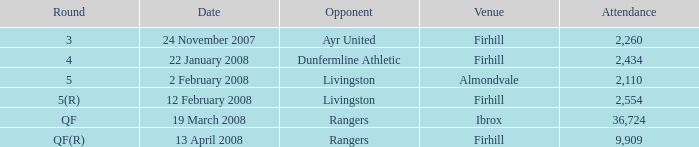What is the mean attendance at a game conducted at firhill for the 5(r) round? 2554.0. 